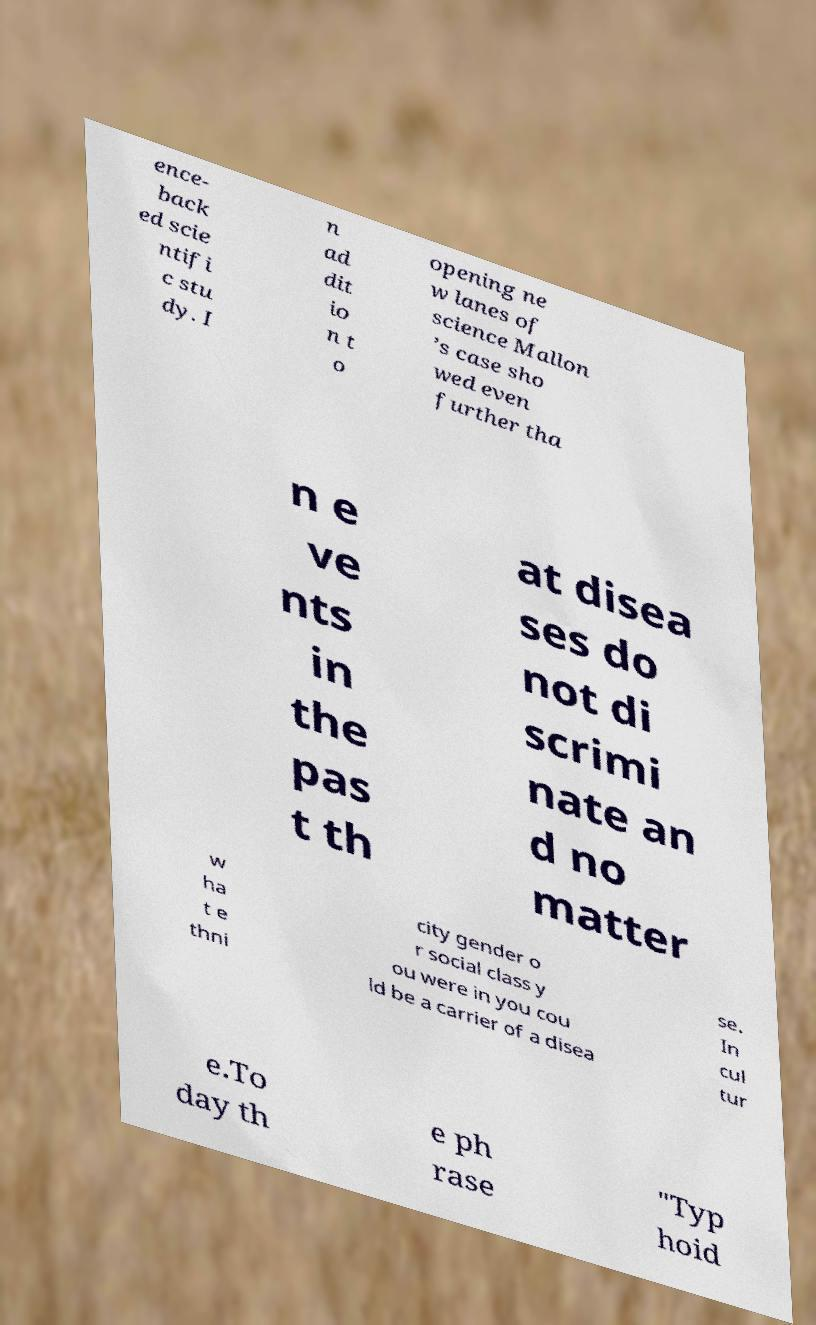I need the written content from this picture converted into text. Can you do that? ence- back ed scie ntifi c stu dy. I n ad dit io n t o opening ne w lanes of science Mallon ’s case sho wed even further tha n e ve nts in the pas t th at disea ses do not di scrimi nate an d no matter w ha t e thni city gender o r social class y ou were in you cou ld be a carrier of a disea se. In cul tur e.To day th e ph rase "Typ hoid 